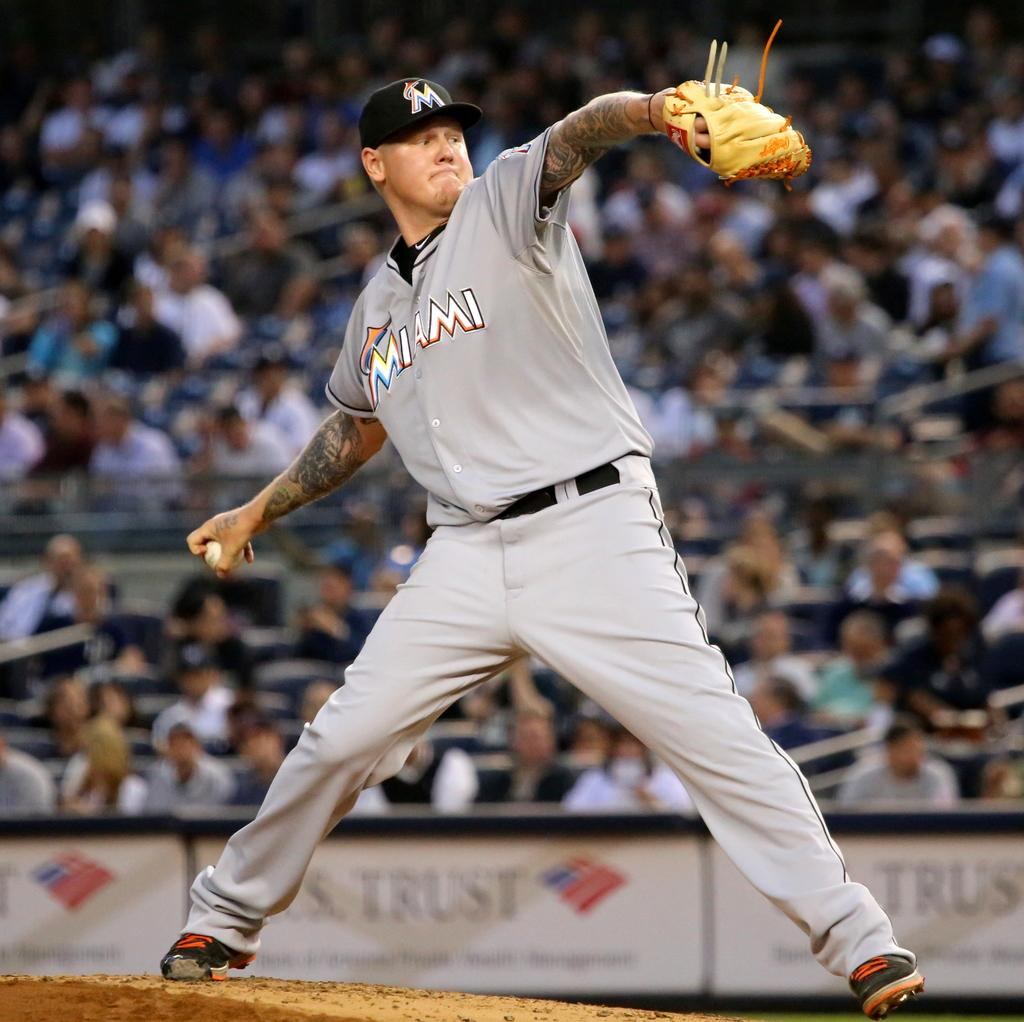<image>
Give a short and clear explanation of the subsequent image. A ball player who's on the Miami team is in the middle of a pitch. 